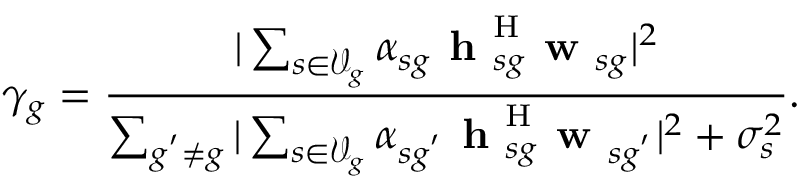<formula> <loc_0><loc_0><loc_500><loc_500>\gamma _ { g } = \frac { | \sum _ { s \in \mathcal { V } _ { g } } \alpha _ { s g } h _ { s g } ^ { H } w _ { s g } | ^ { 2 } } { \sum _ { g ^ { ^ { \prime } } \not = g } | \sum _ { s \in \mathcal { V } _ { g } } \alpha _ { s g ^ { ^ { \prime } } } h _ { s g } ^ { H } w _ { s g ^ { ^ { \prime } } } | ^ { 2 } + \sigma _ { s } ^ { 2 } } .</formula> 